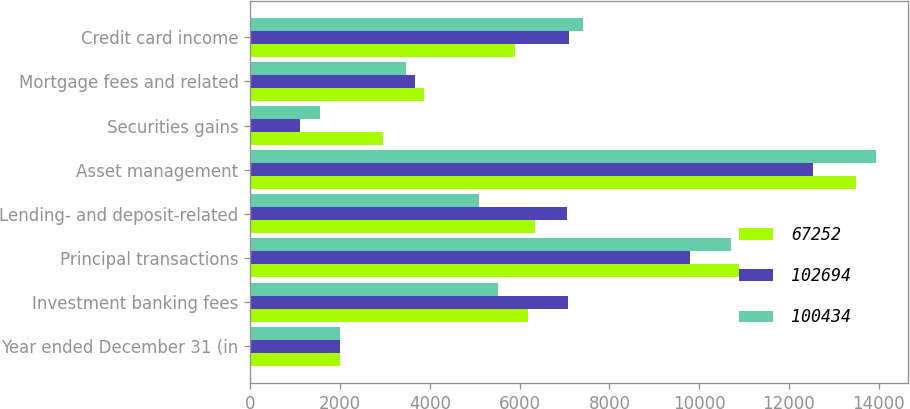Convert chart. <chart><loc_0><loc_0><loc_500><loc_500><stacked_bar_chart><ecel><fcel>Year ended December 31 (in<fcel>Investment banking fees<fcel>Principal transactions<fcel>Lending- and deposit-related<fcel>Asset management<fcel>Securities gains<fcel>Mortgage fees and related<fcel>Credit card income<nl><fcel>67252<fcel>2010<fcel>6190<fcel>10894<fcel>6340<fcel>13499<fcel>2965<fcel>3870<fcel>5891<nl><fcel>102694<fcel>2009<fcel>7087<fcel>9796<fcel>7045<fcel>12540<fcel>1110<fcel>3678<fcel>7110<nl><fcel>100434<fcel>2008<fcel>5526<fcel>10699<fcel>5088<fcel>13943<fcel>1560<fcel>3467<fcel>7419<nl></chart> 